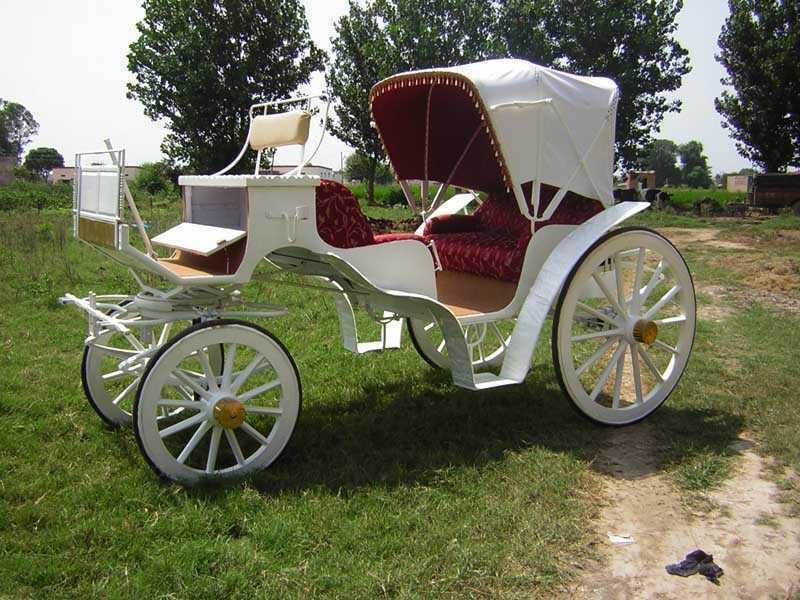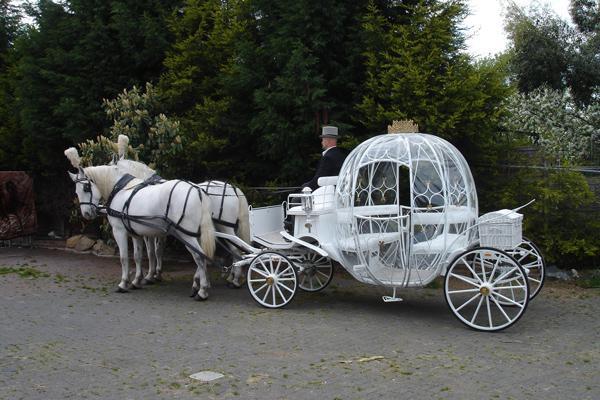The first image is the image on the left, the second image is the image on the right. Examine the images to the left and right. Is the description "The only person in one image of a coach with a rounded top is the driver in his seat." accurate? Answer yes or no. Yes. 